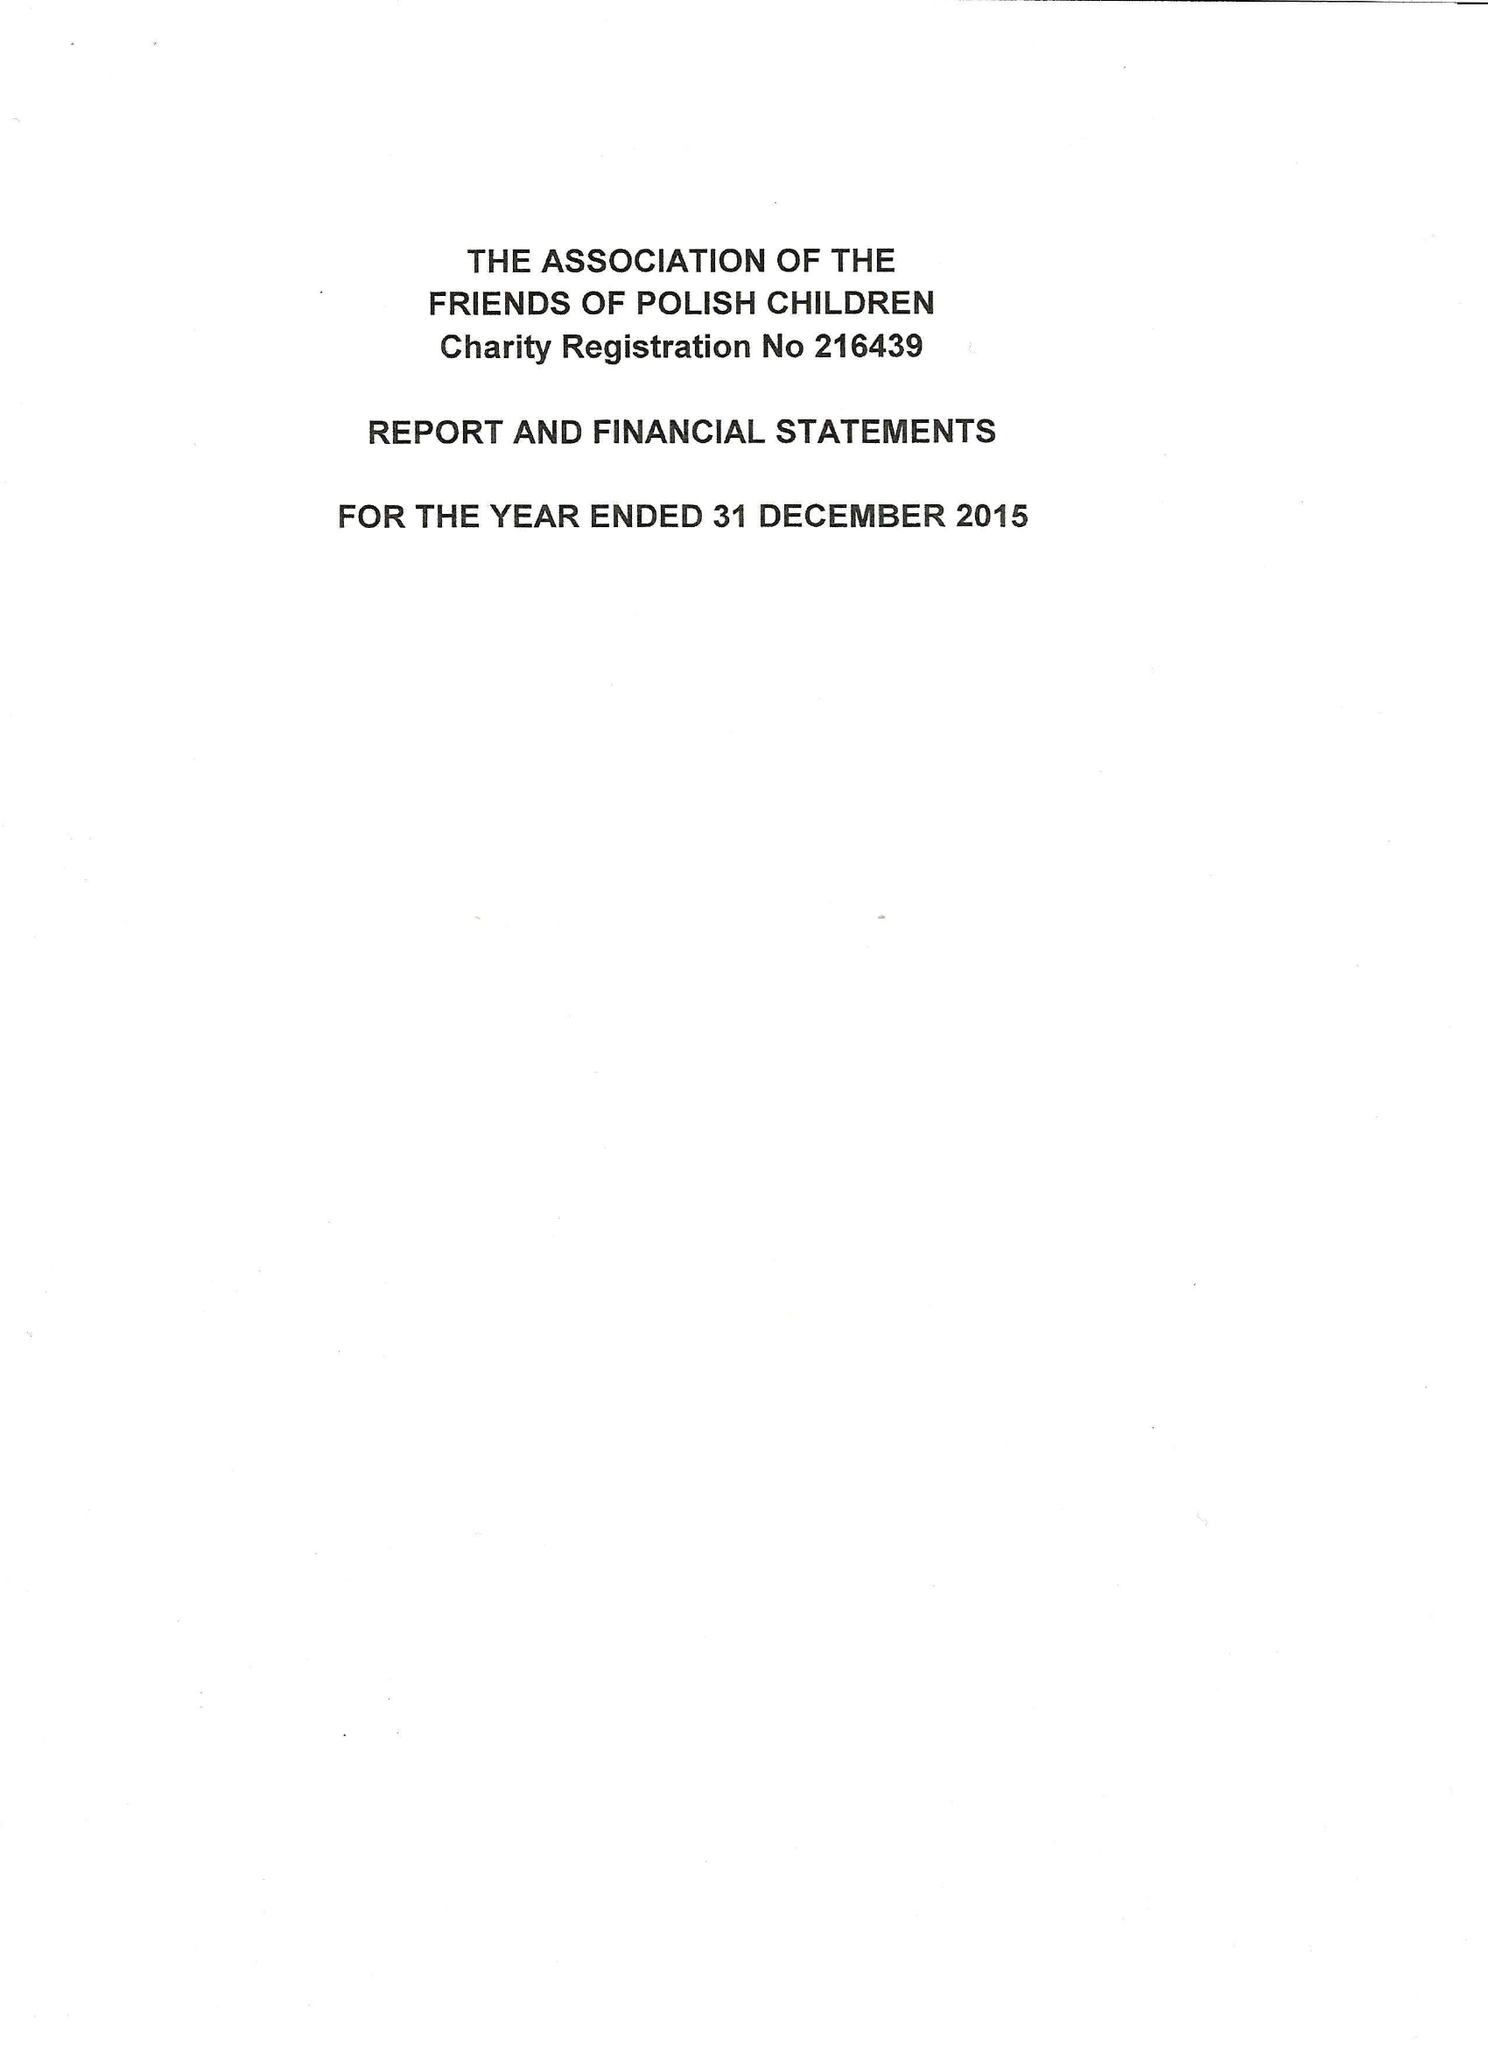What is the value for the spending_annually_in_british_pounds?
Answer the question using a single word or phrase. 104173.00 